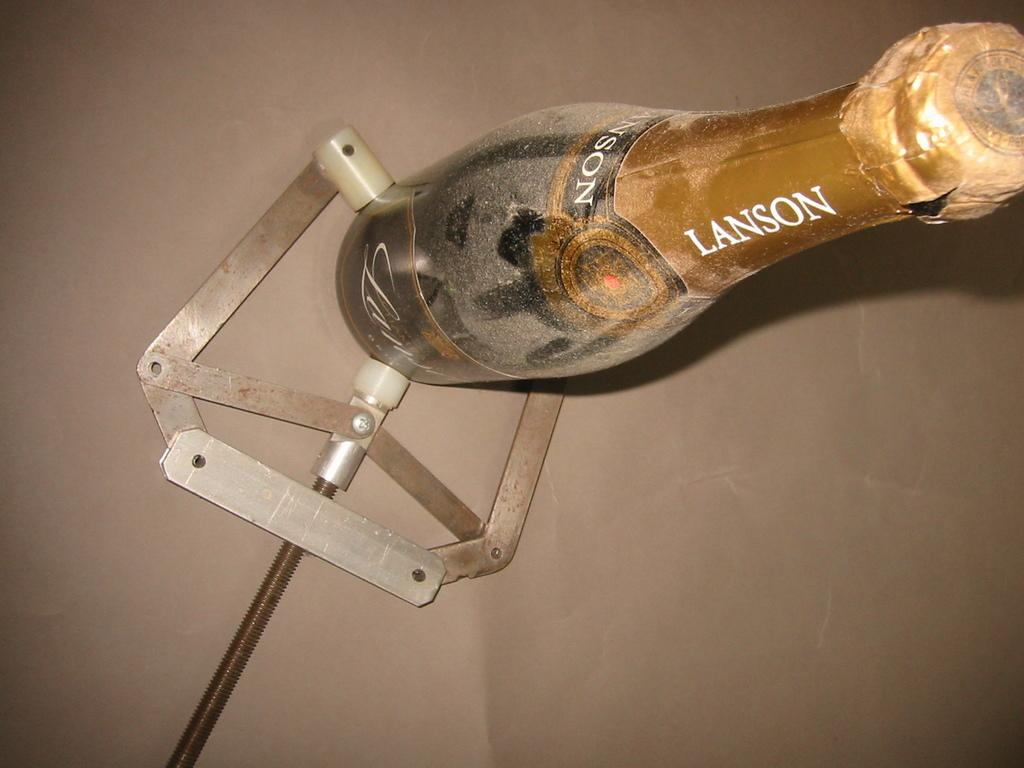<image>
Write a terse but informative summary of the picture. A dusty bottle of Lanson champagne is held by a special metal device. 